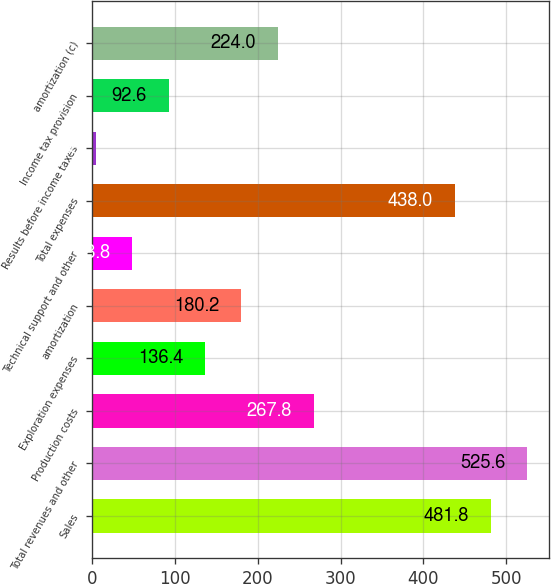<chart> <loc_0><loc_0><loc_500><loc_500><bar_chart><fcel>Sales<fcel>Total revenues and other<fcel>Production costs<fcel>Exploration expenses<fcel>amortization<fcel>Technical support and other<fcel>Total expenses<fcel>Results before income taxes<fcel>Income tax provision<fcel>amortization (c)<nl><fcel>481.8<fcel>525.6<fcel>267.8<fcel>136.4<fcel>180.2<fcel>48.8<fcel>438<fcel>5<fcel>92.6<fcel>224<nl></chart> 